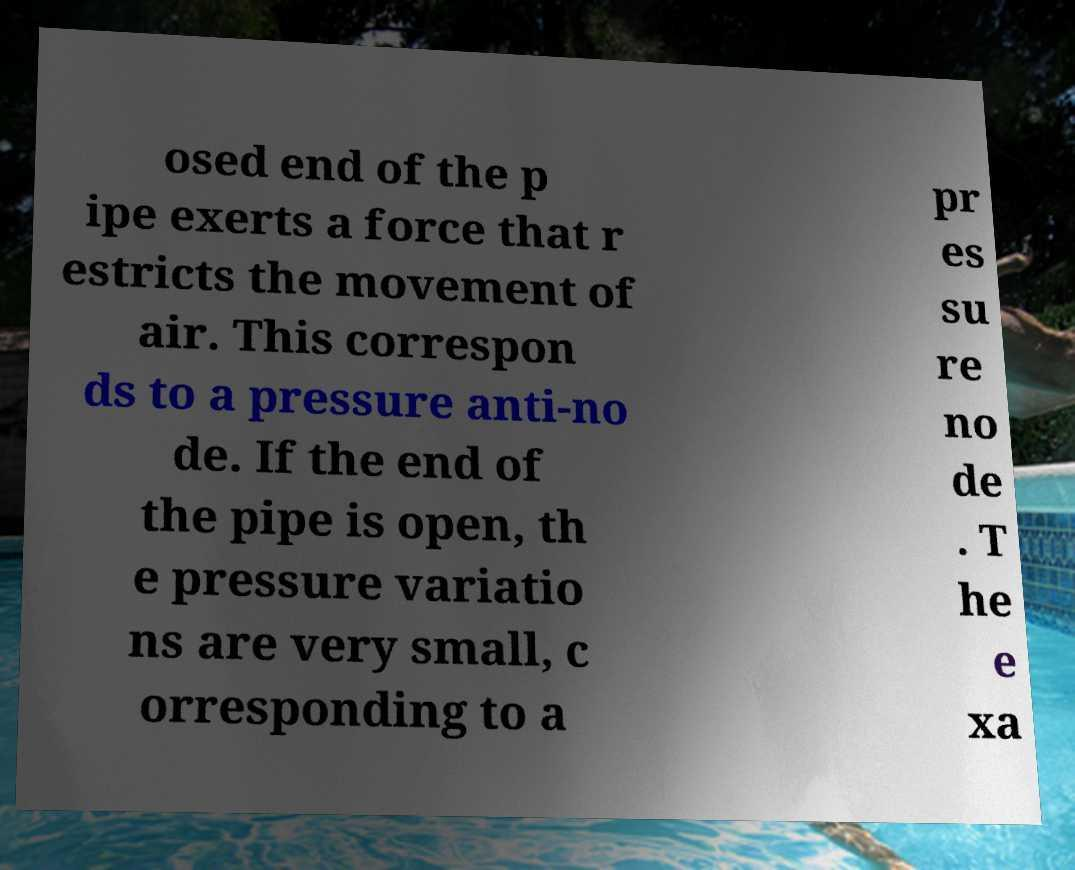Please read and relay the text visible in this image. What does it say? osed end of the p ipe exerts a force that r estricts the movement of air. This correspon ds to a pressure anti-no de. If the end of the pipe is open, th e pressure variatio ns are very small, c orresponding to a pr es su re no de . T he e xa 